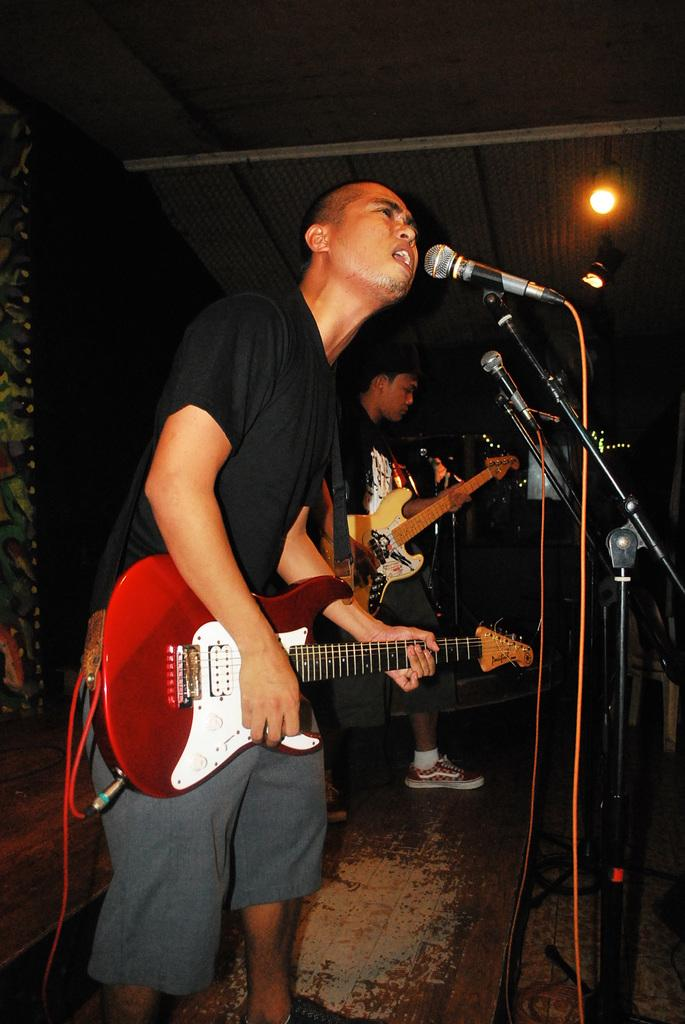What is the main subject of the image? The main subject of the image is men. What are the men doing in the image? The men are standing and holding guitars. Are there any animals present in the image? Yes, there are mice in front of the men. What type of camera is being used by the men in the image? There is no camera present in the image; the men are holding guitars. What is the title of the song the men are playing in the image? The image does not provide any information about the song being played, as it only shows the men holding guitars. 